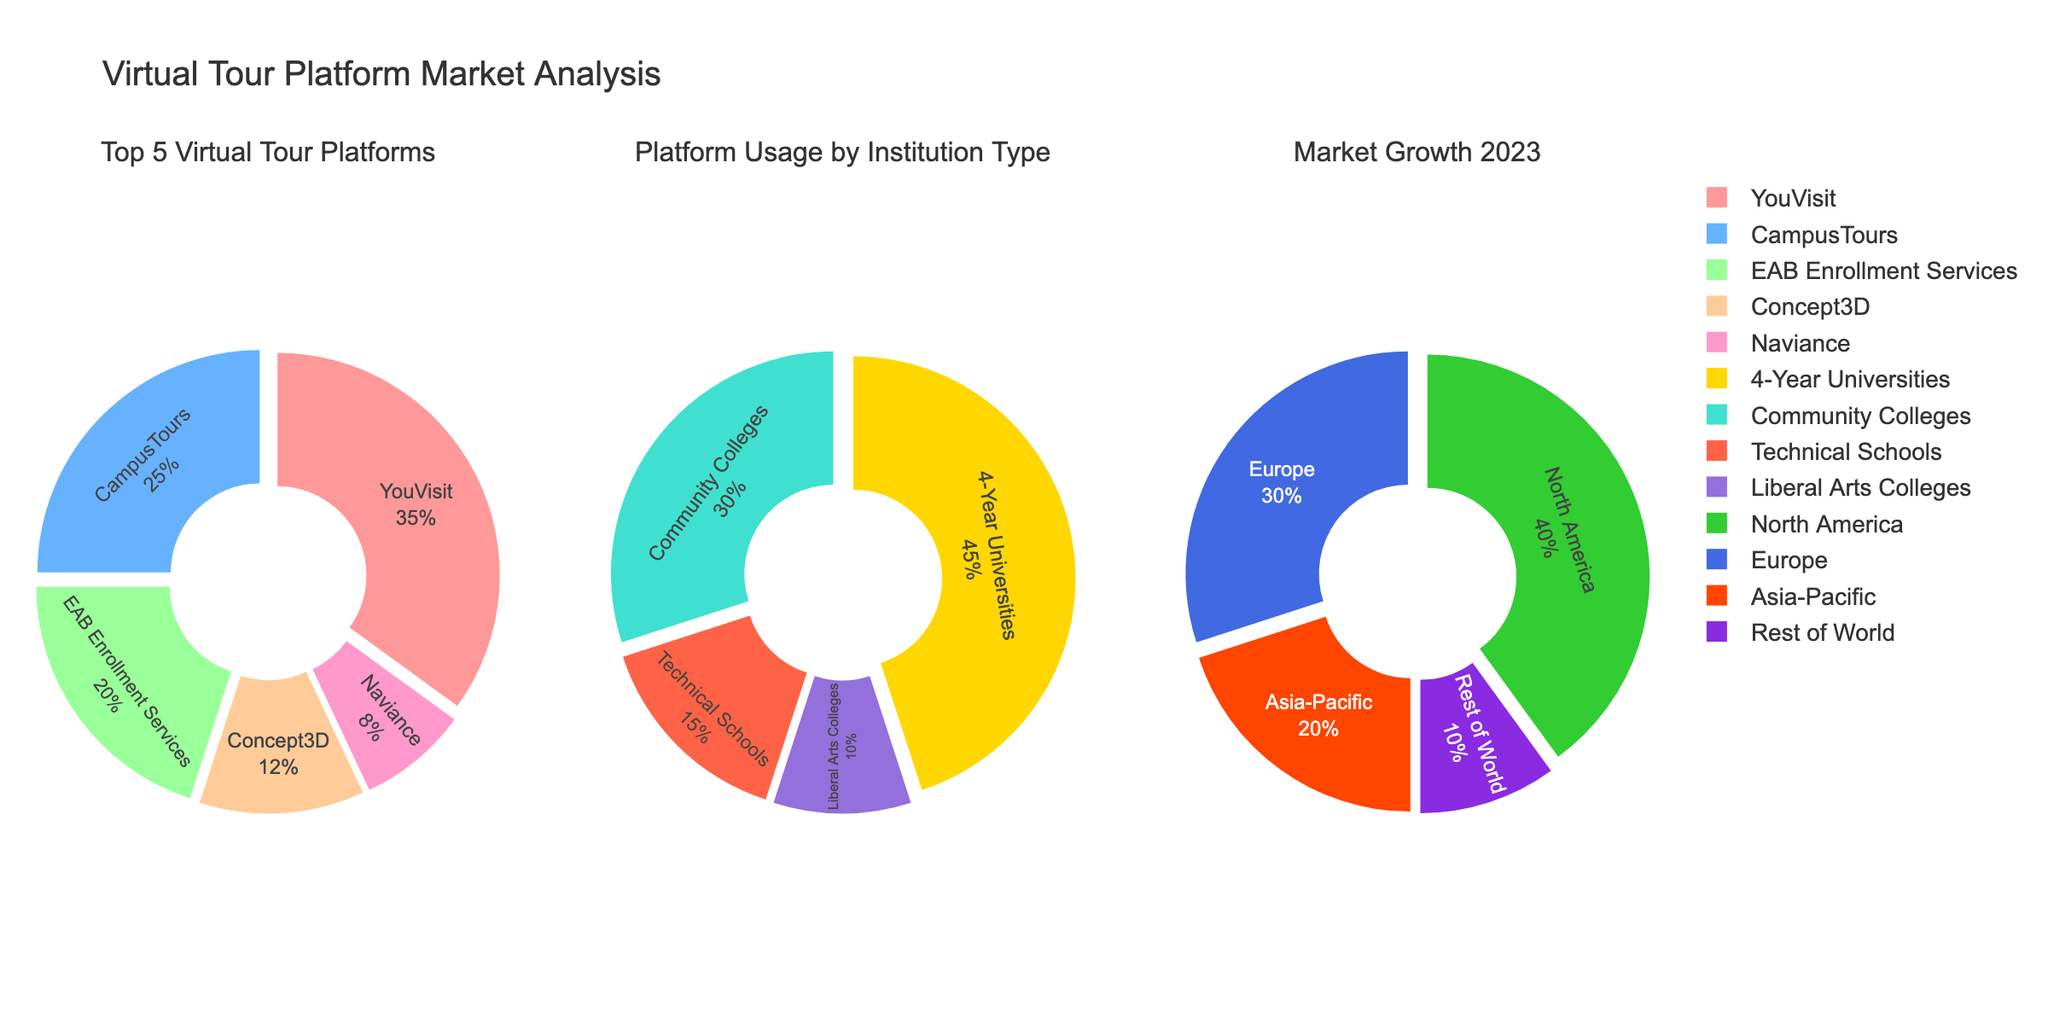What's the title of the figure? The title is indicated at the top of the figure. It provides a context or descriptive label for the entire figure.
Answer: "Virtual Tour Platform Market Analysis" What is the market share of 'YouVisit' among the top 5 virtual tour platforms? Locate the pie chart labeled 'Top 5 Virtual Tour Platforms'. From the chart sectors, find the share labeled 'YouVisit' and read its percentage value.
Answer: 35% How many institution types are represented in the 'Platform Usage by Institution Type' pie chart? Look at the pie chart labeled 'Platform Usage by Institution Type' and count the number of distinct labels.
Answer: 4 Which region has the smallest share in 'Market Growth 2023'? Check the 'Market Growth 2023' pie chart and identify the region with the smallest segment.
Answer: Rest of World What is the combined market share of 'Community Colleges' and 'Technical Schools' in the platform usage pie chart? In the 'Platform Usage by Institution Type' pie chart, locate the shares for 'Community Colleges' and 'Technical Schools'. Add their percentage values together (30 + 15).
Answer: 45% Which platform has the second-largest market share among the top 5 virtual tour platforms? Observe the 'Top 5 Virtual Tour Platforms' pie chart and identify the sector with the second-largest percentage after 'YouVisit'.
Answer: CampusTours What is the difference in market share between 'Europe' and 'Asia-Pacific' in 'Market Growth 2023'? In the 'Market Growth 2023' pie chart, subtract the percentage value of 'Asia-Pacific' from 'Europe' (30 - 20).
Answer: 10% How does the market share of 'North America' compare to 'Rest of World' in 'Market Growth 2023'? Compare the segment size for 'North America' and 'Rest of World' in the 'Market Growth 2023' pie chart, noting which is larger and by how much (40 > 10).
Answer: North America has 30% more What shares of the 'Platform Usage by Institution Type' pie chart are held by '4-Year Universities' and 'Liberal Arts Colleges'? Locate the shares for '4-Year Universities' and 'Liberal Arts Colleges' in the 'Platform Usage by Institution Type' pie chart and note down their values.
Answer: 45% and 10% Which market has the most similar share between 'Concept3D' in the top 5 platforms and 'Liberal Arts Colleges' in platform usage? Compare the percentage shares in each relevant chart, identifying the sectors with similar values—'Concept3D' in 'Top 5 Virtual Tour Platforms' (12%) and 'Liberal Arts Colleges' in 'Platform Usage by Institution Type' (10%).
Answer: Concept3D and Liberal Arts Colleges 